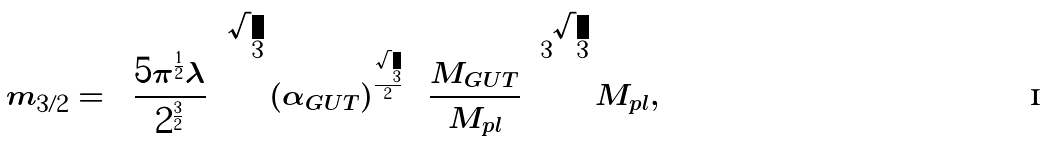<formula> <loc_0><loc_0><loc_500><loc_500>m _ { 3 / 2 } = \left ( \frac { 5 \pi ^ { \frac { 1 } { 2 } } \lambda } { 2 ^ { \frac { 3 } { 2 } } } \right ) ^ { \sqrt { 3 } } \left ( \alpha _ { G U T } \right ) ^ { \frac { \sqrt { 3 } } { 2 } } \left ( \frac { M _ { G U T } } { M _ { p l } } \right ) ^ { 3 \sqrt { 3 } } M _ { p l } ,</formula> 